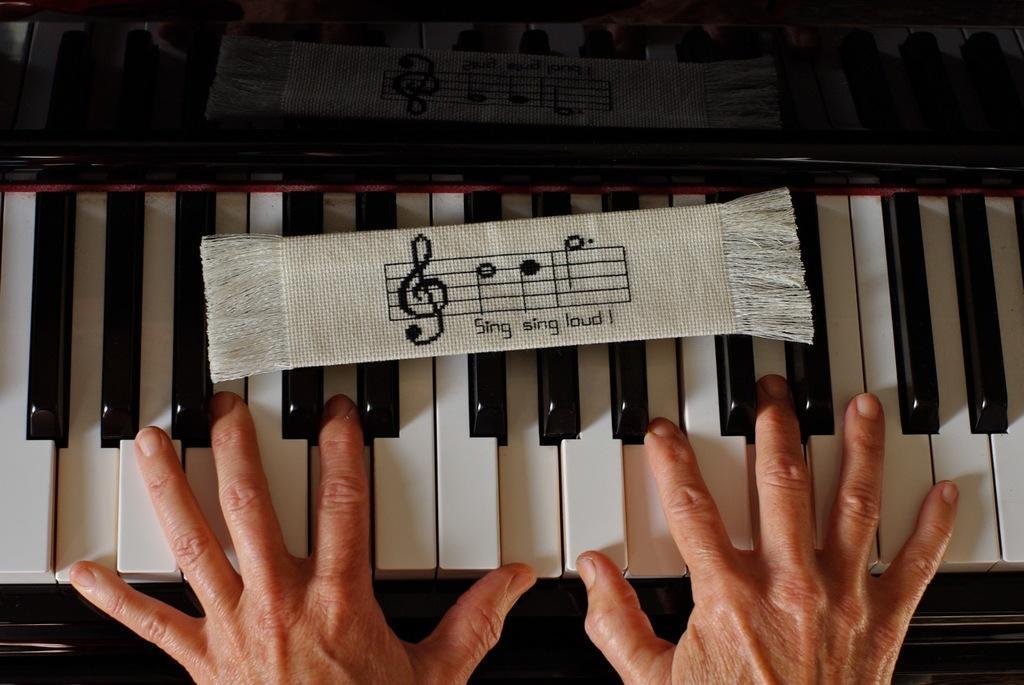In one or two sentences, can you explain what this image depicts? In this image i can see a human hand and a piano. 